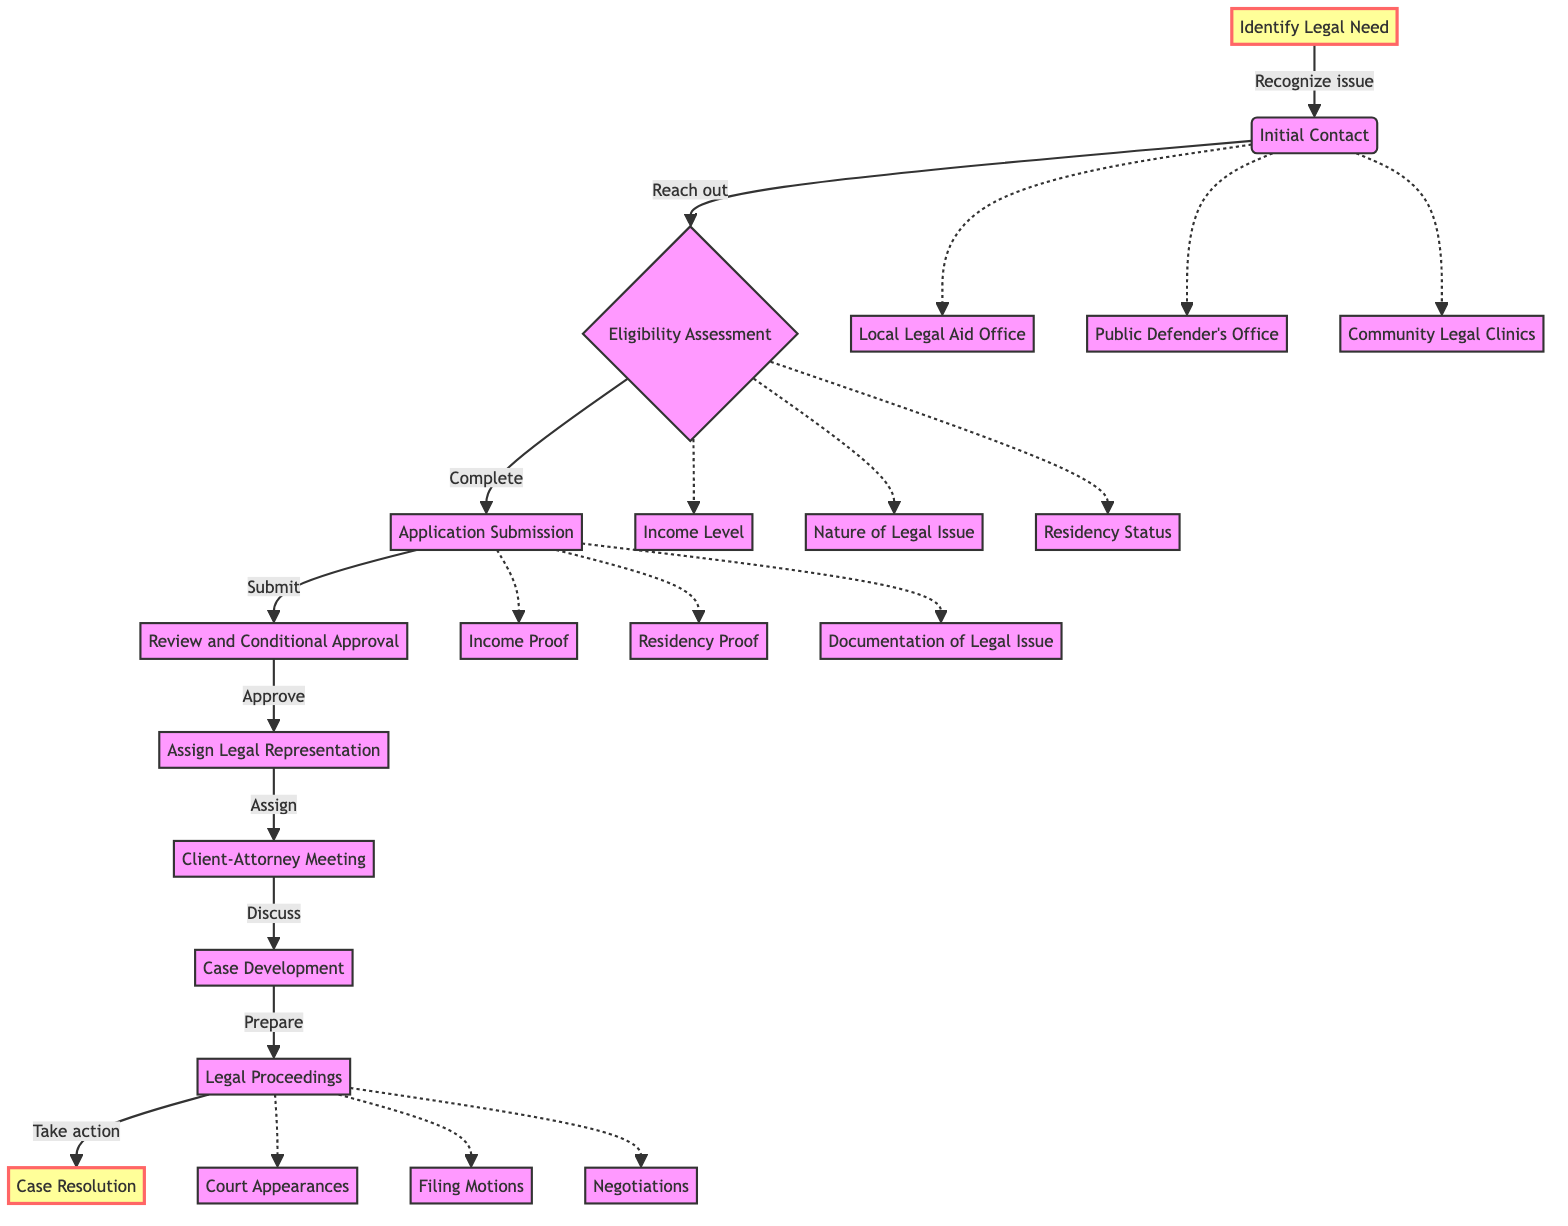What is the first step in accessing legal aid? The first step is "Identify Legal Need," where individuals recognize there is a legal issue that needs professional assistance.
Answer: Identify Legal Need How many types of initial contacts are listed? The diagram lists three types of initial contacts: "Local Legal Aid Office," "Public Defender's Office," and "Community Legal Clinics."
Answer: Three What document is required for the Application Submission step? The documents required include "Income Proof," "Residency Proof," and "Documentation of Legal Issue."
Answer: Three What comes after Client-Attorney Meeting? After the "Client-Attorney Meeting," the next step is "Case Development." This indicates that discussions lead to collaborative preparation.
Answer: Case Development How many criteria are used for the Eligibility Assessment? There are three criteria listed for the Eligibility Assessment: "Income Level," "Nature of Legal Issue," and "Residency Status."
Answer: Three What type of actions are taken during Legal Proceedings? The actions taken during "Legal Proceedings" include "Court Appearances," "Filing Motions," and "Negotiations."
Answer: Court Appearances, Filing Motions, Negotiations Which step directly leads to assigning legal representation? The step that leads directly to "Assign Legal Representation" is "Review and Conditional Approval," where the legal aid office reviews the application.
Answer: Review and Conditional Approval What is the final outcome of the process depicted in the diagram? The final outcome of the process is "Case Resolution," where the legal case reaches a conclusion.
Answer: Case Resolution Which step involves the initial meeting between client and attorney? The step that involves the initial meeting between the client and attorney is "Client-Attorney Meeting."
Answer: Client-Attorney Meeting 